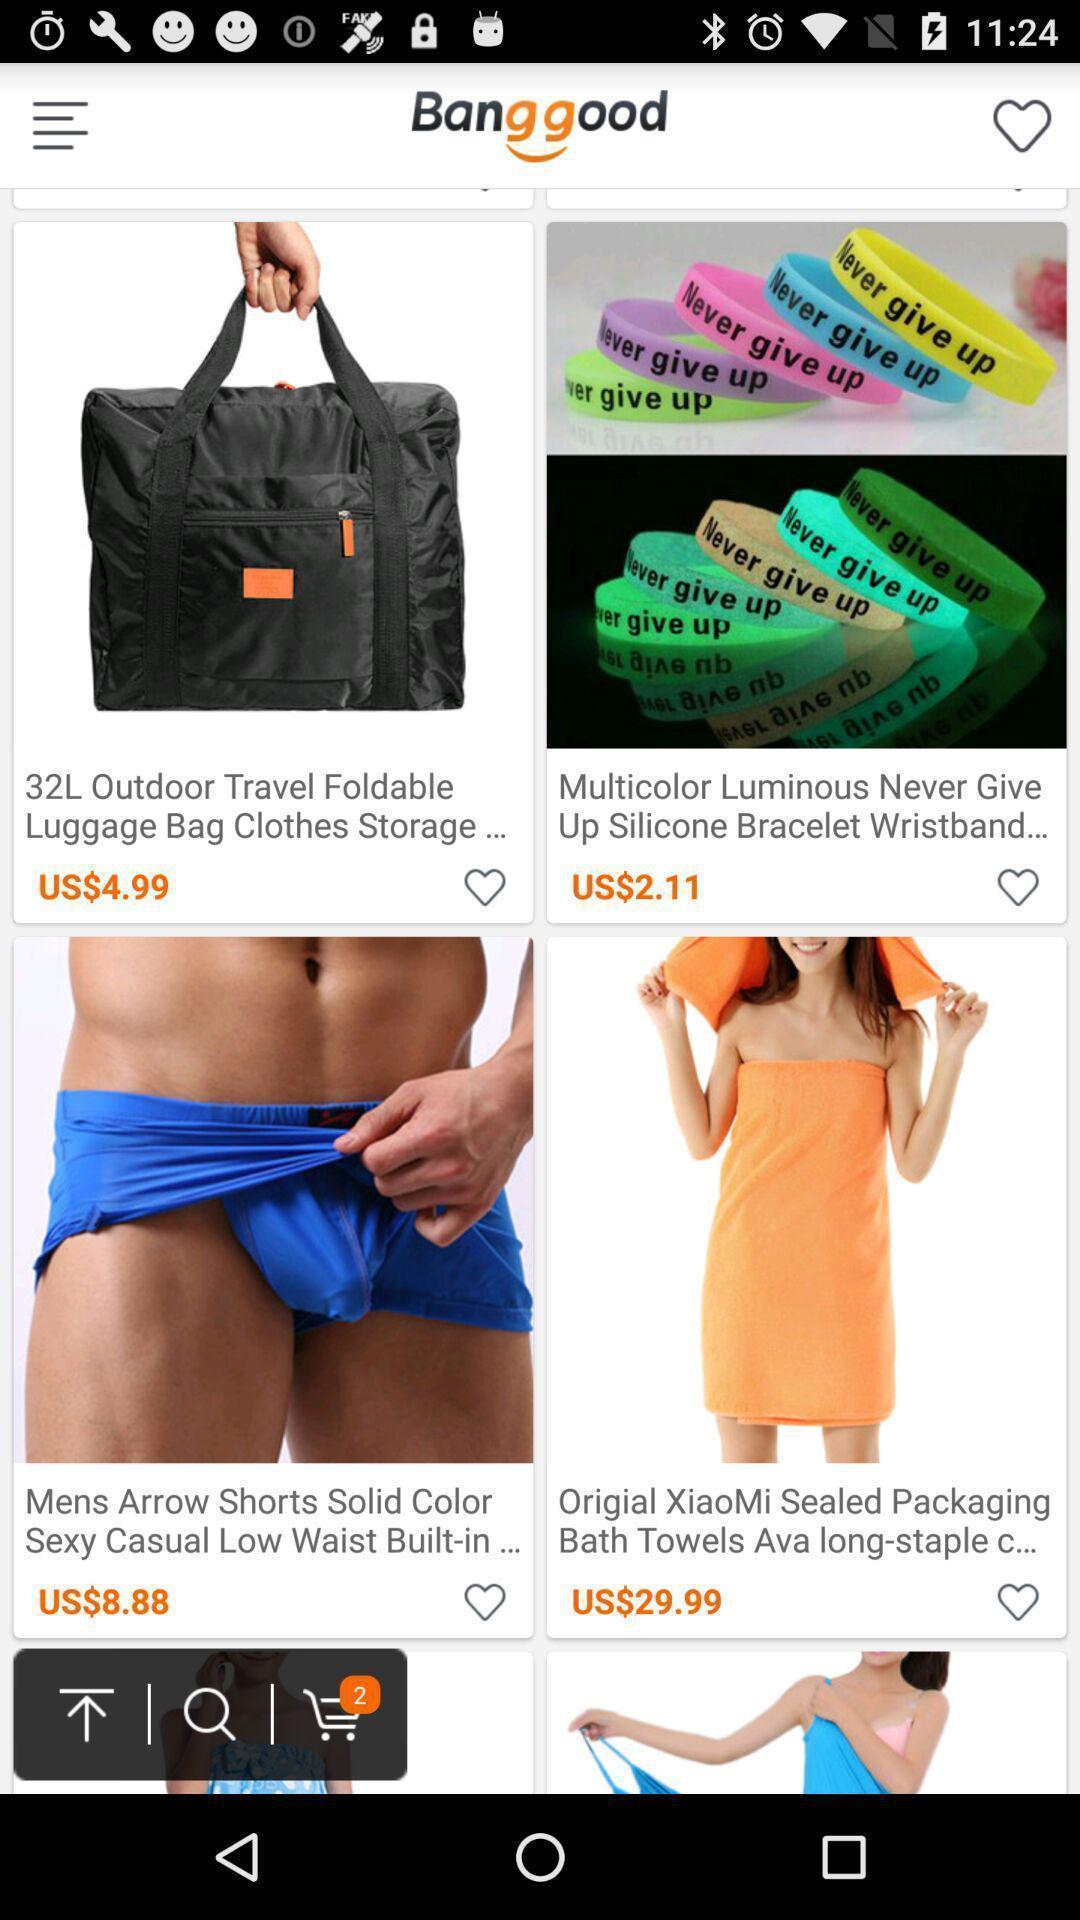Provide a description of this screenshot. Screen displaying of a shopping application. 